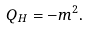<formula> <loc_0><loc_0><loc_500><loc_500>Q _ { H } = - m ^ { 2 } .</formula> 